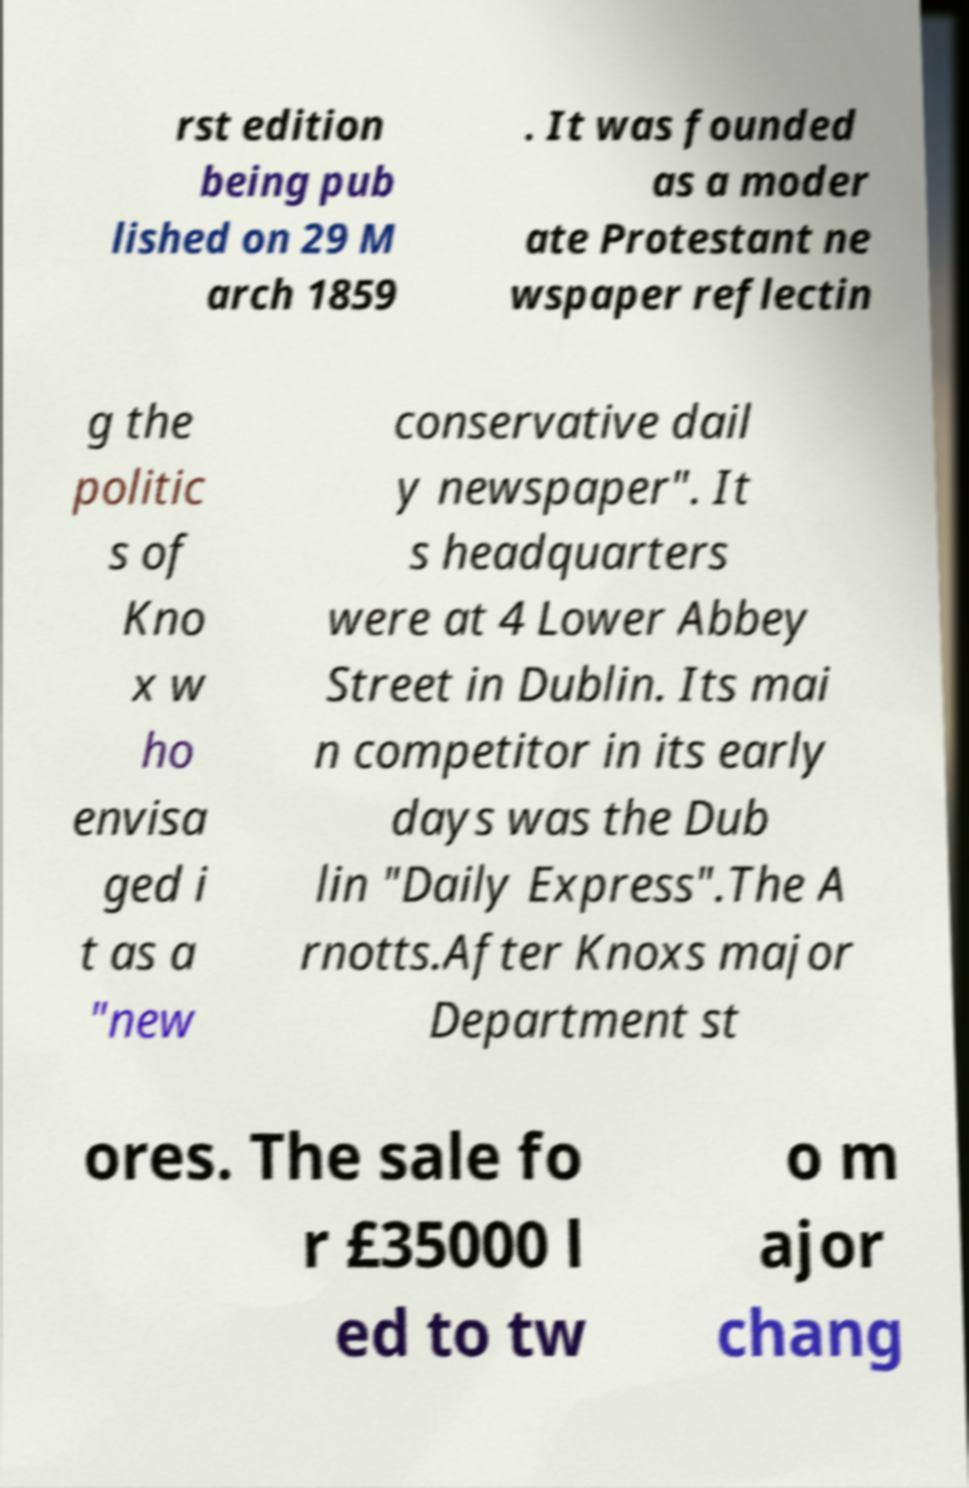Please read and relay the text visible in this image. What does it say? rst edition being pub lished on 29 M arch 1859 . It was founded as a moder ate Protestant ne wspaper reflectin g the politic s of Kno x w ho envisa ged i t as a "new conservative dail y newspaper". It s headquarters were at 4 Lower Abbey Street in Dublin. Its mai n competitor in its early days was the Dub lin "Daily Express".The A rnotts.After Knoxs major Department st ores. The sale fo r £35000 l ed to tw o m ajor chang 